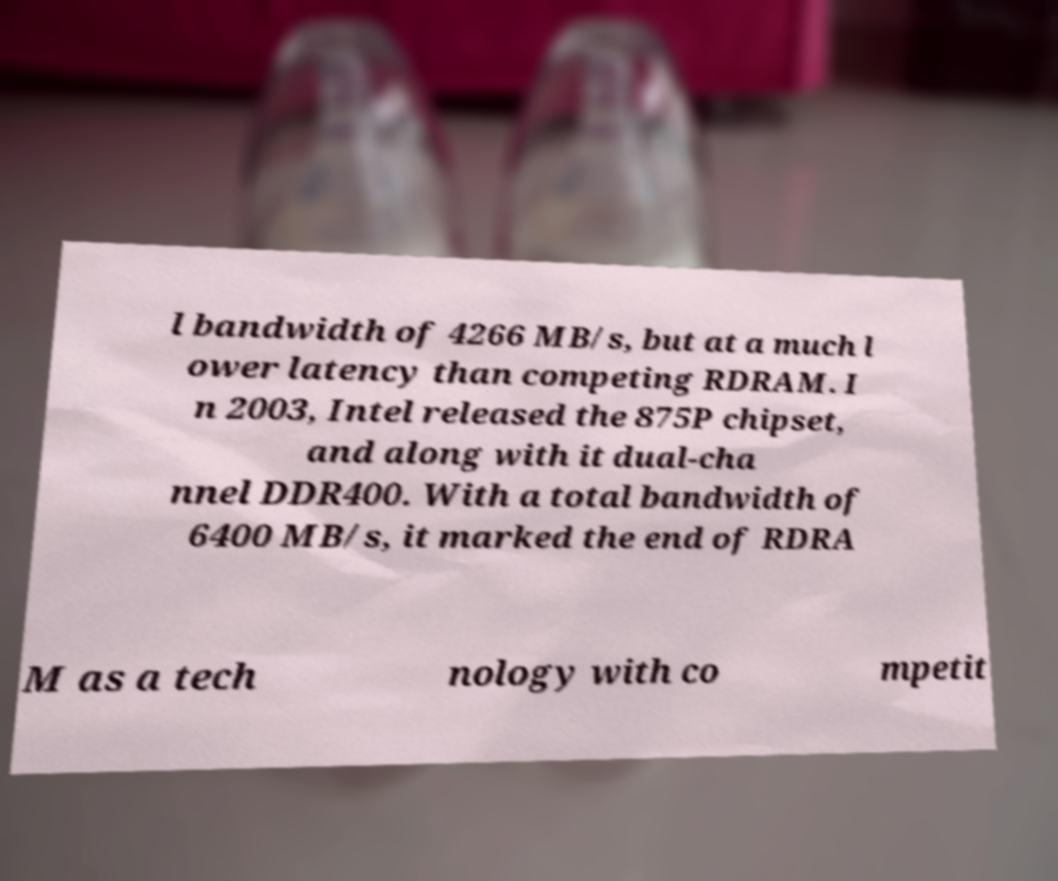What messages or text are displayed in this image? I need them in a readable, typed format. l bandwidth of 4266 MB/s, but at a much l ower latency than competing RDRAM. I n 2003, Intel released the 875P chipset, and along with it dual-cha nnel DDR400. With a total bandwidth of 6400 MB/s, it marked the end of RDRA M as a tech nology with co mpetit 